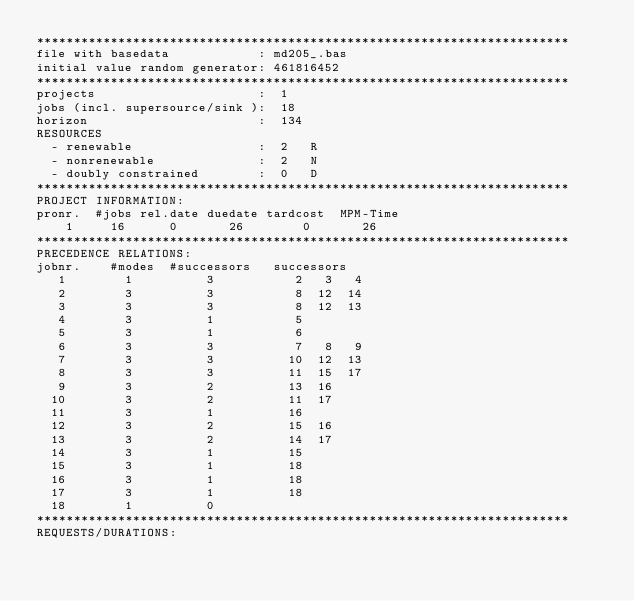<code> <loc_0><loc_0><loc_500><loc_500><_ObjectiveC_>************************************************************************
file with basedata            : md205_.bas
initial value random generator: 461816452
************************************************************************
projects                      :  1
jobs (incl. supersource/sink ):  18
horizon                       :  134
RESOURCES
  - renewable                 :  2   R
  - nonrenewable              :  2   N
  - doubly constrained        :  0   D
************************************************************************
PROJECT INFORMATION:
pronr.  #jobs rel.date duedate tardcost  MPM-Time
    1     16      0       26        0       26
************************************************************************
PRECEDENCE RELATIONS:
jobnr.    #modes  #successors   successors
   1        1          3           2   3   4
   2        3          3           8  12  14
   3        3          3           8  12  13
   4        3          1           5
   5        3          1           6
   6        3          3           7   8   9
   7        3          3          10  12  13
   8        3          3          11  15  17
   9        3          2          13  16
  10        3          2          11  17
  11        3          1          16
  12        3          2          15  16
  13        3          2          14  17
  14        3          1          15
  15        3          1          18
  16        3          1          18
  17        3          1          18
  18        1          0        
************************************************************************
REQUESTS/DURATIONS:</code> 